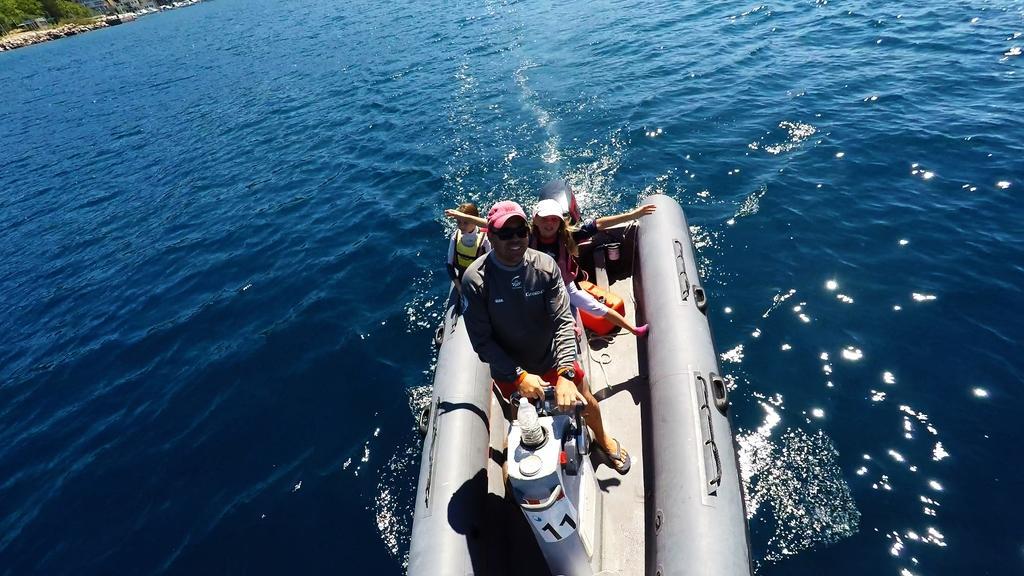In one or two sentences, can you explain what this image depicts? In this image we can see this person and two children wearing life jackets are sitting on the inflatable boat which is floating on the water. Here we can see the trees in the background. 